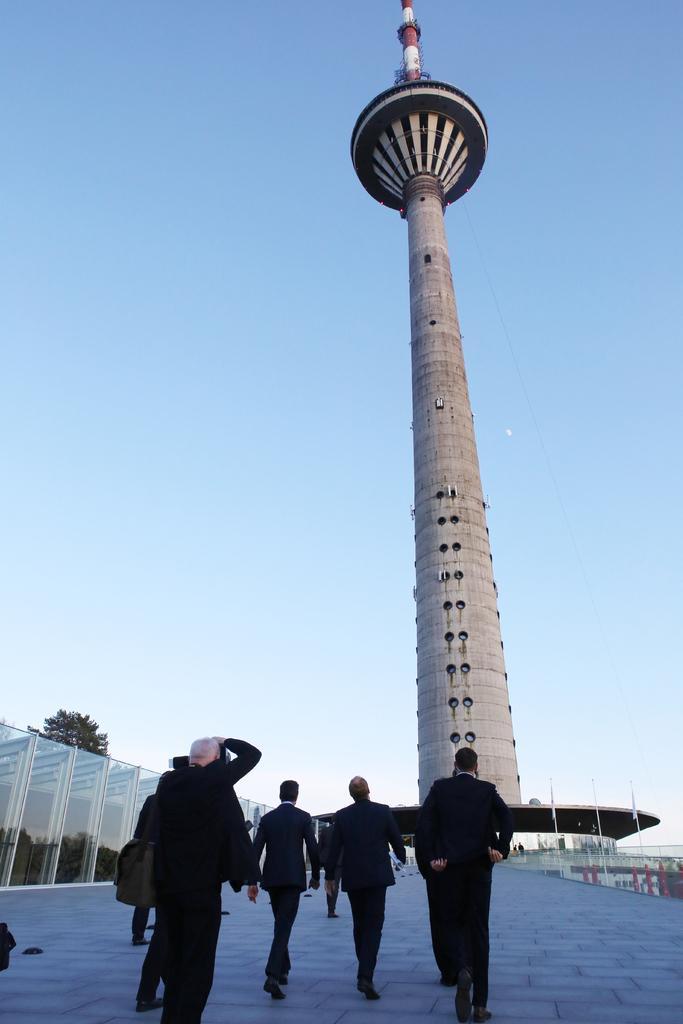Can you describe this image briefly? This picture describes about group of people, few are standing and few are walking, in front of them we can see few glasses, trees and a tower. 